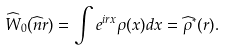Convert formula to latex. <formula><loc_0><loc_0><loc_500><loc_500>\widehat { W } _ { 0 } ( \widehat { n } r ) = \int e ^ { i r x } \rho ( x ) d x = \widehat { \rho } ^ { * } ( r ) .</formula> 